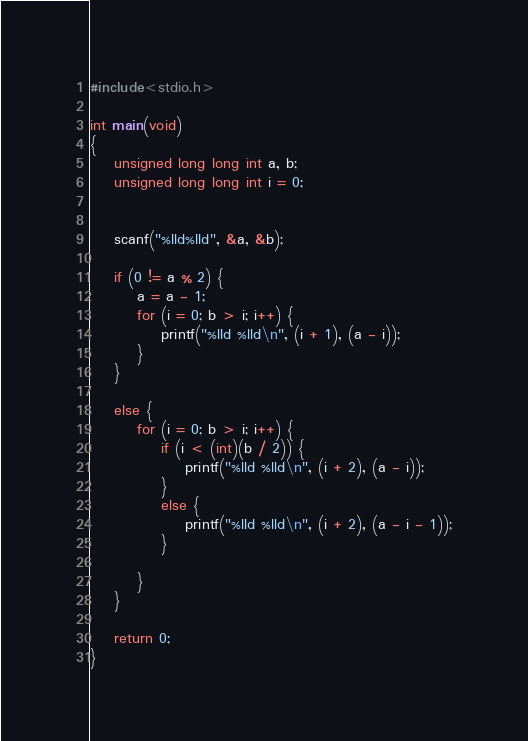Convert code to text. <code><loc_0><loc_0><loc_500><loc_500><_C_>#include<stdio.h>

int main(void)
{
	unsigned long long int a, b;
	unsigned long long int i = 0;
	

	scanf("%lld%lld", &a, &b);

	if (0 != a % 2) {
		a = a - 1;
		for (i = 0; b > i; i++) {
			printf("%lld %lld\n", (i + 1), (a - i));
		}
	}

	else {
		for (i = 0; b > i; i++) {
			if (i < (int)(b / 2)) {
				printf("%lld %lld\n", (i + 2), (a - i));
			}
			else {
				printf("%lld %lld\n", (i + 2), (a - i - 1));
			}

		}
	}

	return 0;
}</code> 